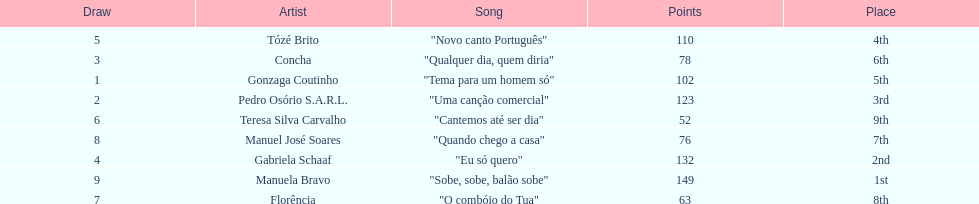Which artist came in last place? Teresa Silva Carvalho. 